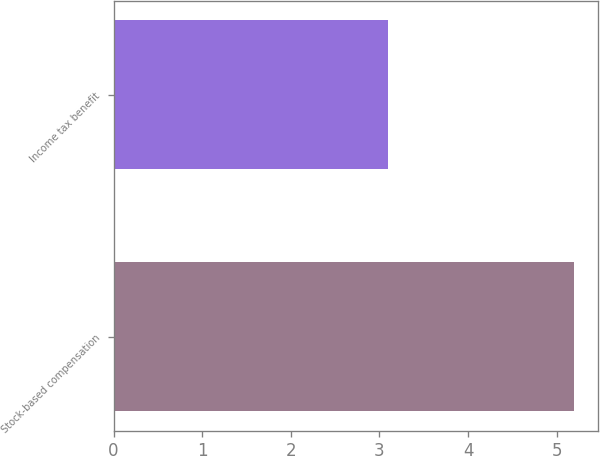<chart> <loc_0><loc_0><loc_500><loc_500><bar_chart><fcel>Stock-based compensation<fcel>Income tax benefit<nl><fcel>5.2<fcel>3.1<nl></chart> 